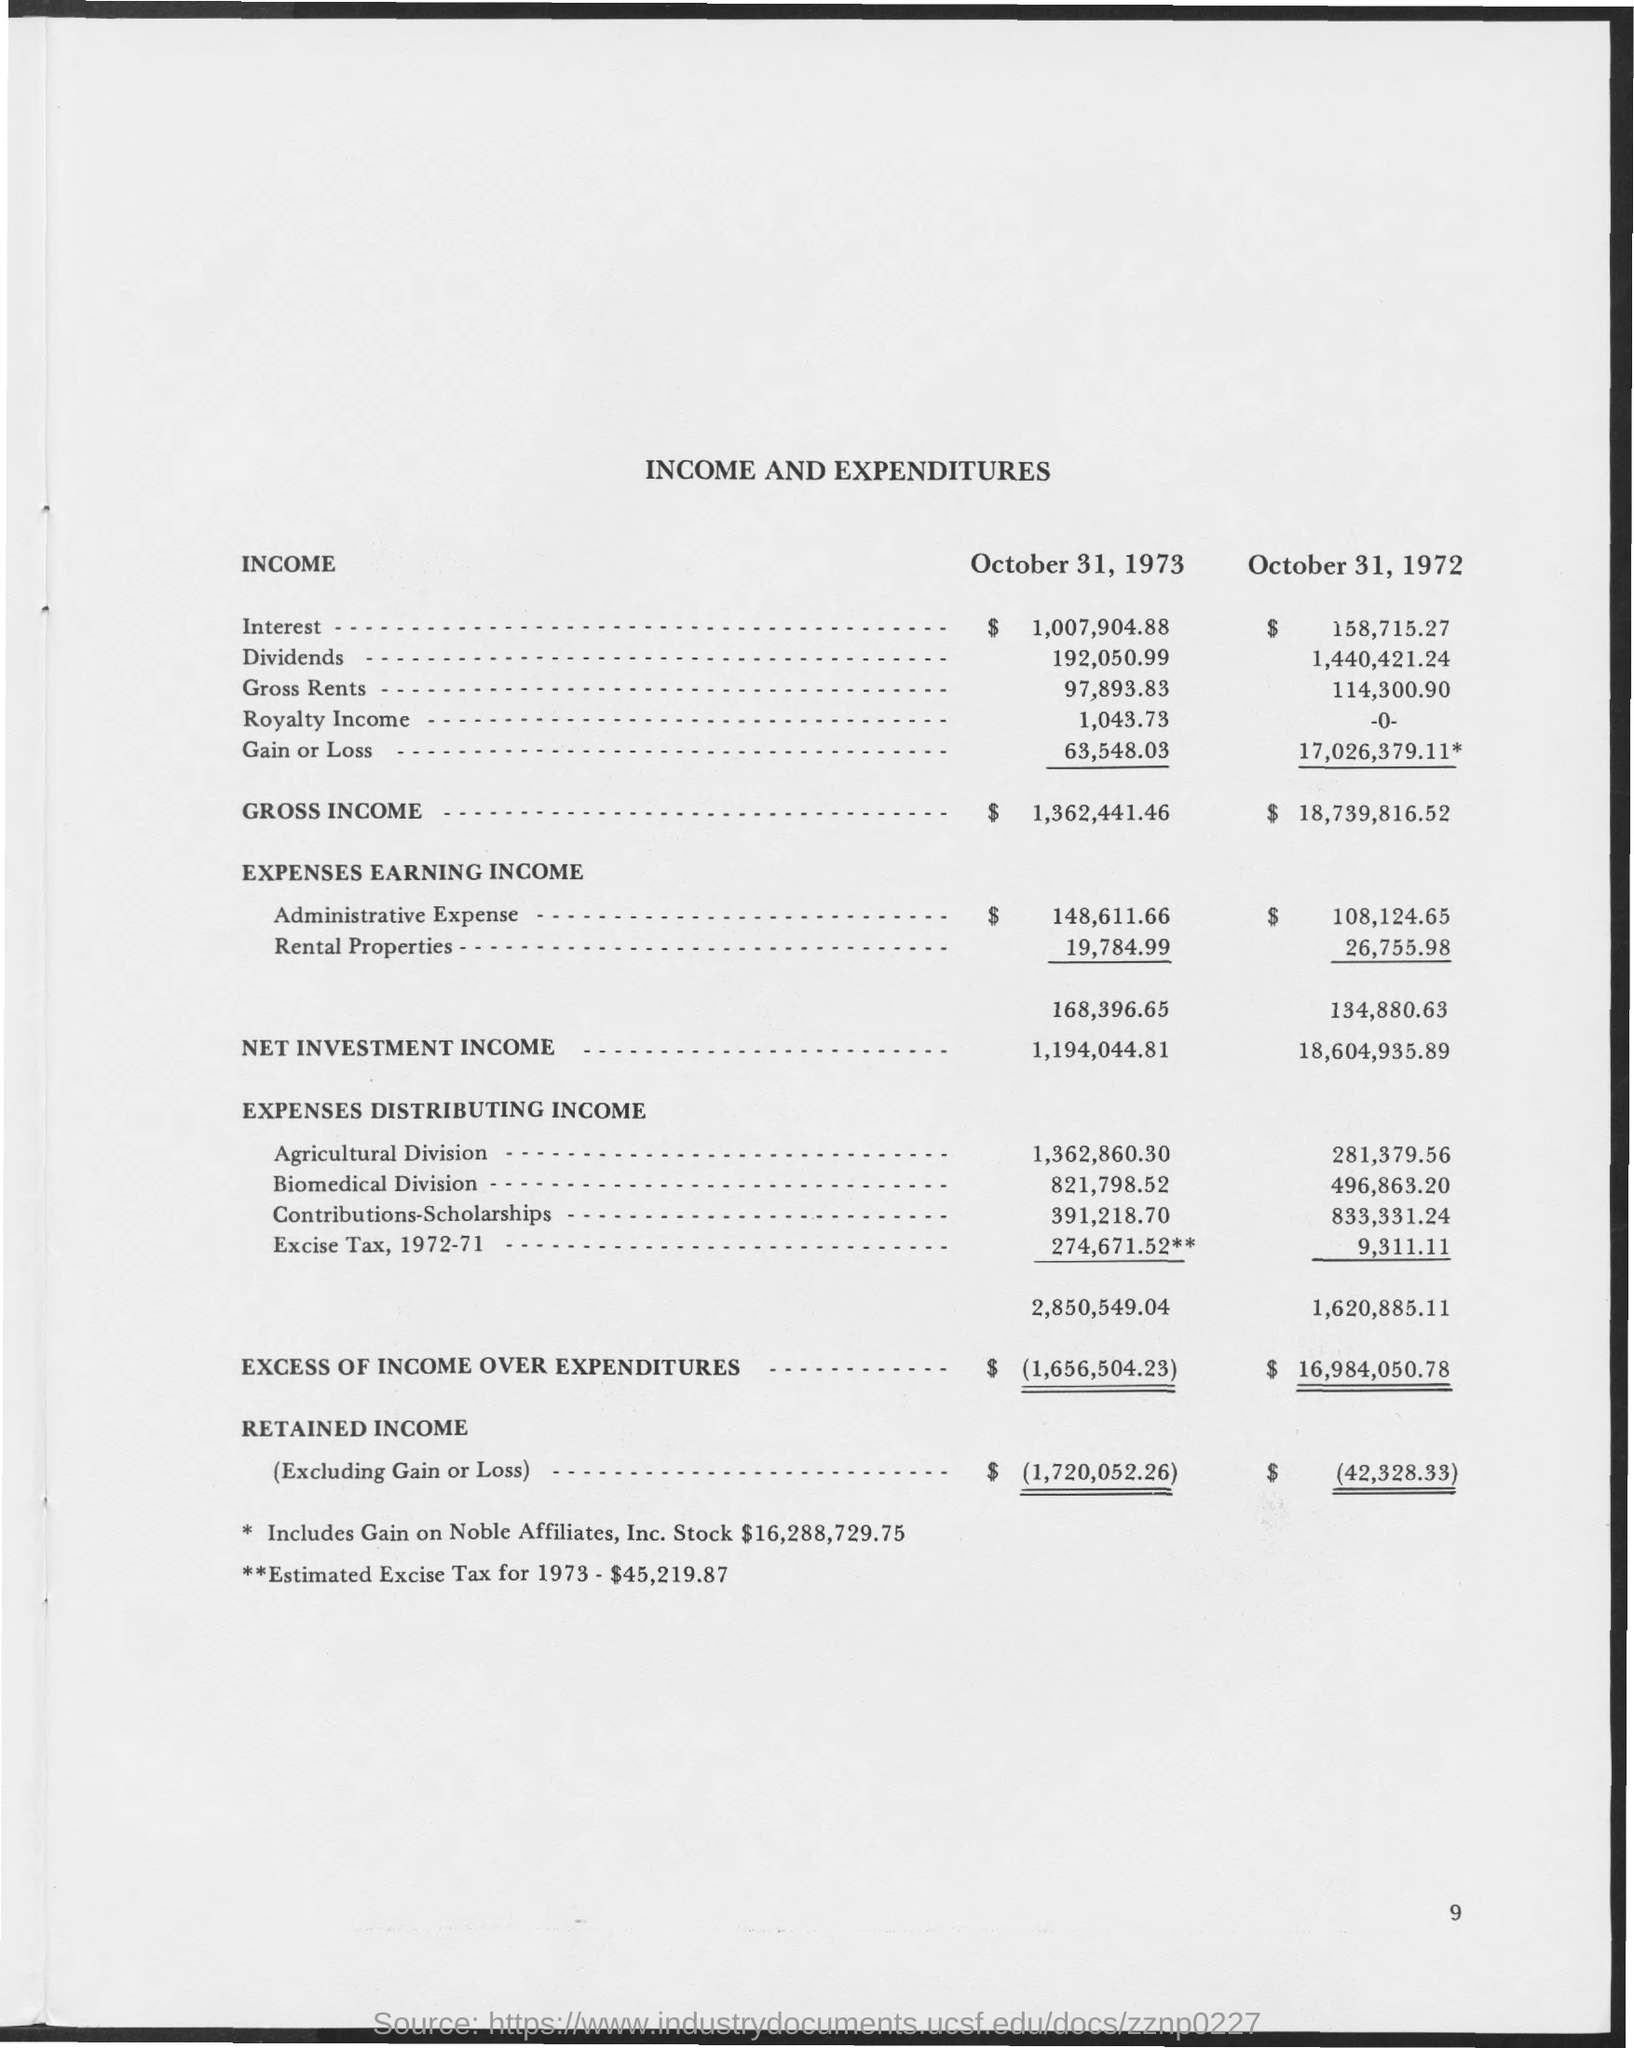Point out several critical features in this image. The excess of income over expenditures as of October 31, 1972, was $16,984,050.78. On October 31, 1973, the expenses for earning income from rental properties amounted to $19,784.99. The net investment income as of October 31, 1972, was 18,604,935.89. The gross income as of October 31, 1973, was 1,362,441.46. The excess of income over expenditures as of October 31, 1973, was $1,656,504.23. 